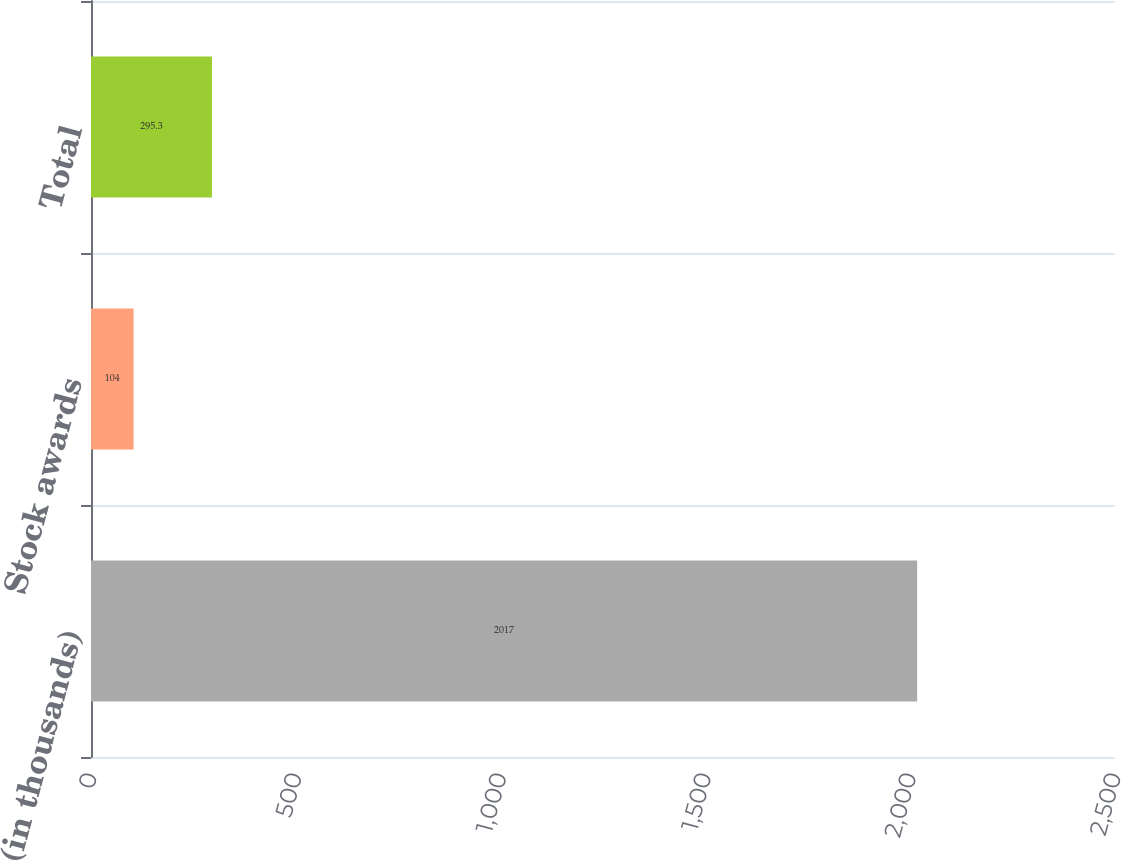Convert chart to OTSL. <chart><loc_0><loc_0><loc_500><loc_500><bar_chart><fcel>(in thousands)<fcel>Stock awards<fcel>Total<nl><fcel>2017<fcel>104<fcel>295.3<nl></chart> 